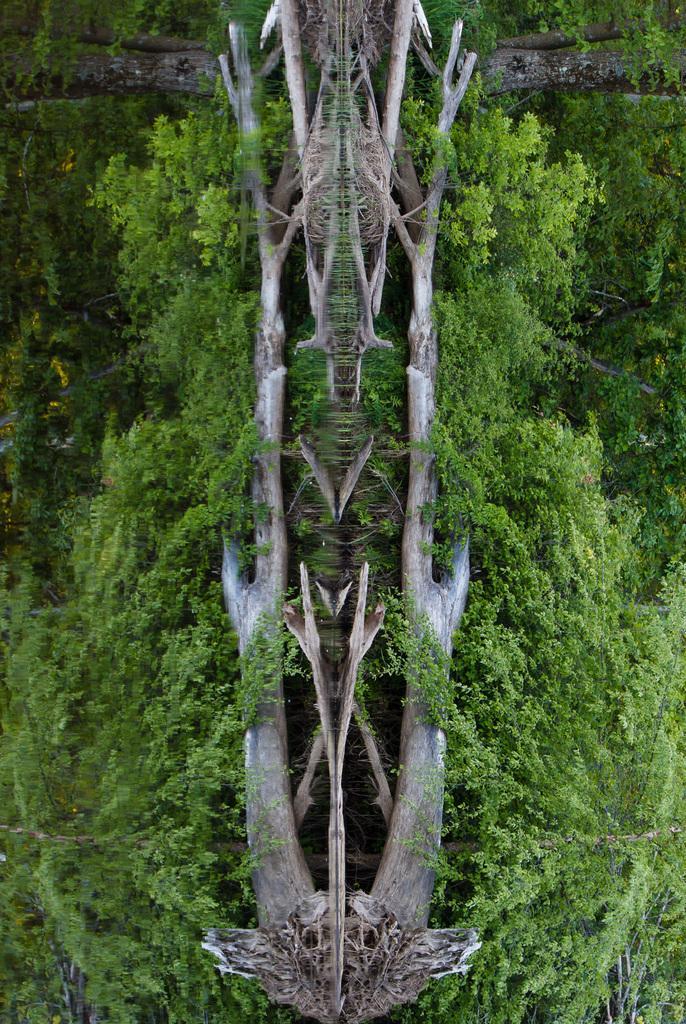Please provide a concise description of this image. This is an edited image. In this image we can see the bark of a tree and a group of trees. 